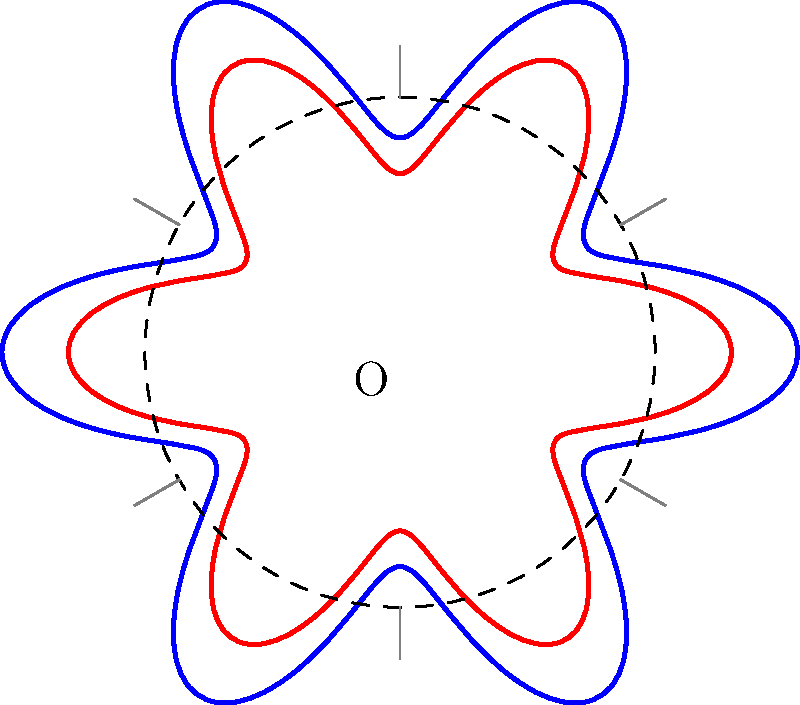The rose window of St. Mary's Cathedral follows a polar equation $r = 1 + 0.3\cos(6\theta)$. How many axes of symmetry does this design have? To determine the number of axes of symmetry in the rose window design, we need to analyze the given polar equation:

1. The equation is of the form $r = 1 + 0.3\cos(6\theta)$
2. The key factor here is the coefficient of $\theta$ inside the cosine function, which is 6.
3. This coefficient determines the number of "petals" or lobes in the design, as well as the number of axes of symmetry.
4. For a general equation $r = a + b\cos(n\theta)$ or $r = a + b\sin(n\theta)$, where $n$ is an integer:
   - If $n$ is even, there are $n$ axes of symmetry
   - If $n$ is odd, there are $2n$ axes of symmetry
5. In this case, $n = 6$, which is even.
6. Therefore, the number of axes of symmetry is equal to $n$, which is 6.

The axes of symmetry are represented by the gray lines in the diagram, which divide the window into 6 equal parts.
Answer: 6 